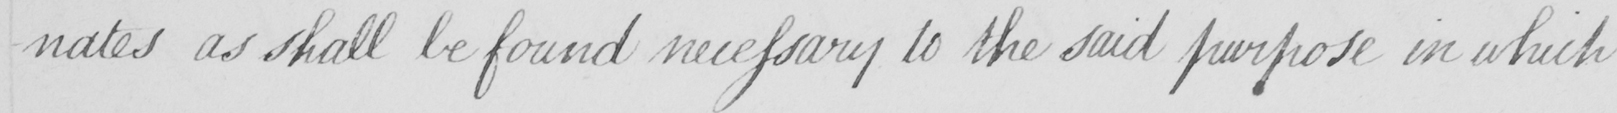What does this handwritten line say? -nates as shall be found necessary to the said purpose in which 